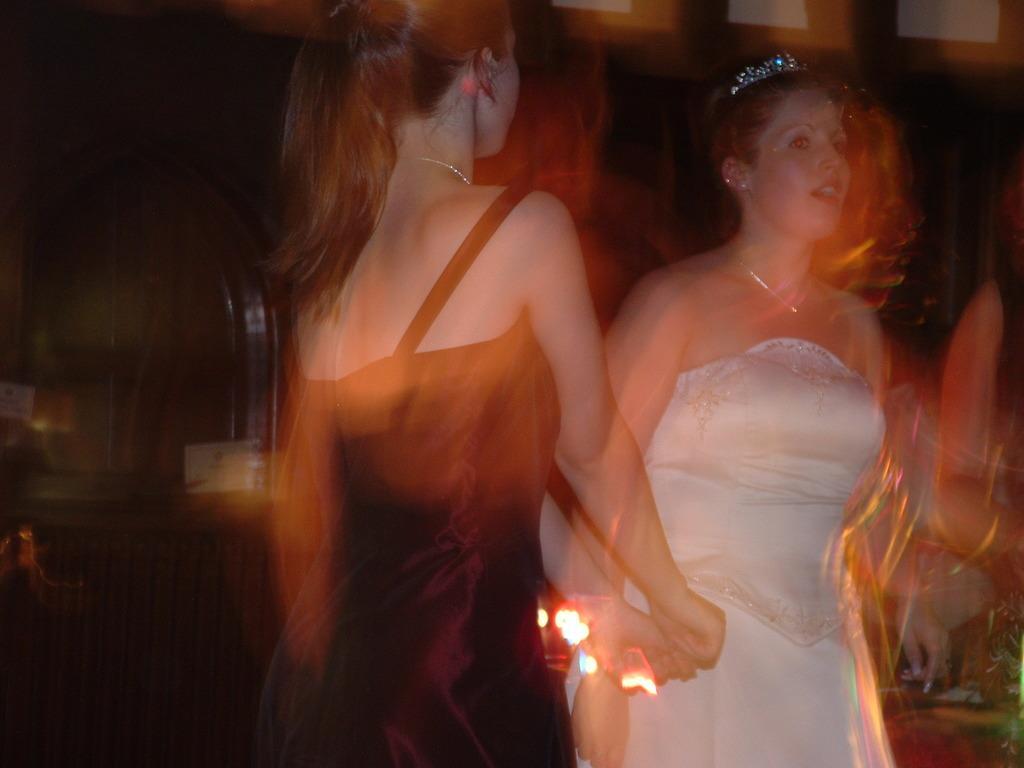Please provide a concise description of this image. In this image I can see two women. One person is wearing white dress and the other person is wearing black dress. The background is blurry. 